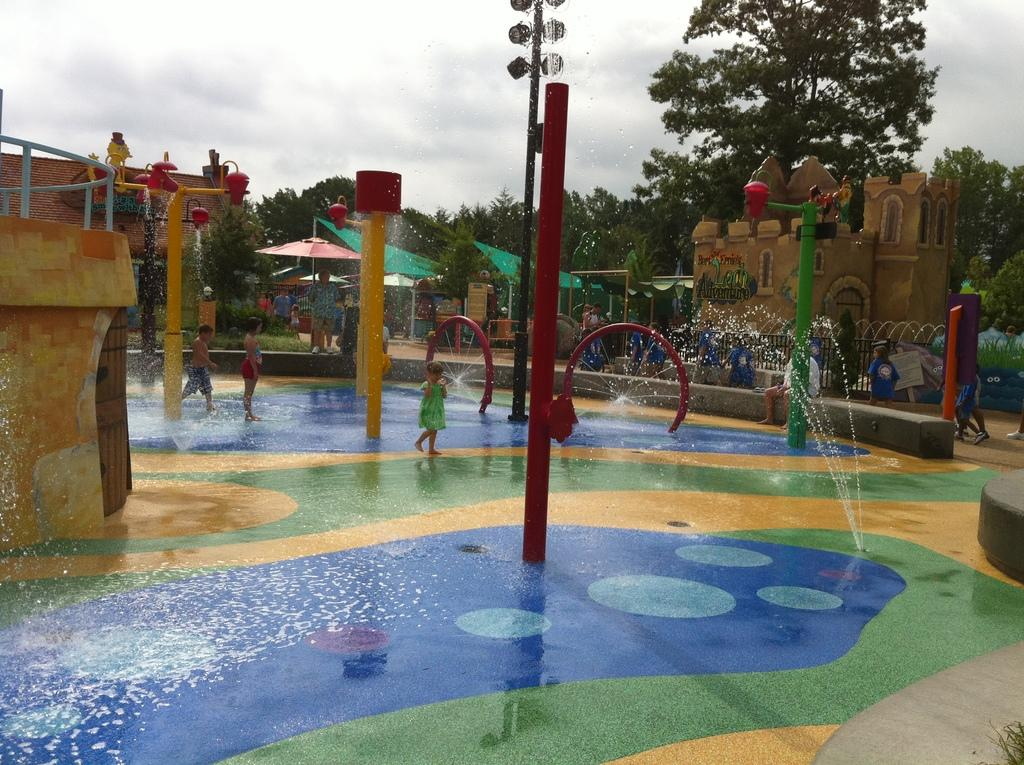What type of location is shown in the image? The image depicts a water park. What are the kids doing in the image? The kids are playing near a water adventure. Can you describe the actions of the people in the image? Some persons are walking along the way. What can be seen in the background of the image? There are trees and a cloudy sky in the background. What type of bag is being used by the woman in the image? There is no woman present in the image, and therefore no bag can be observed. 